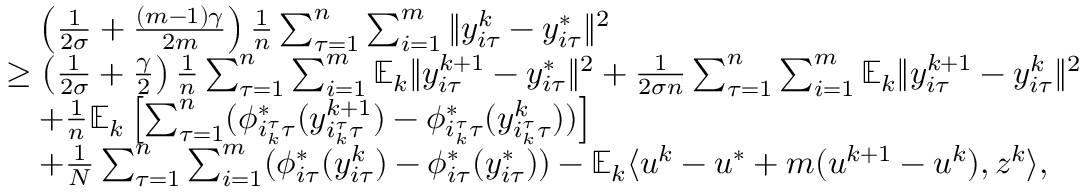<formula> <loc_0><loc_0><loc_500><loc_500>\begin{array} { r l } & { \quad \left ( \frac { 1 } { 2 \sigma } + \frac { ( m - 1 ) \gamma } { 2 m } \right ) \frac { 1 } { n } \sum _ { \tau = 1 } ^ { n } \sum _ { i = 1 } ^ { m } \| y _ { i \tau } ^ { k } - y _ { i \tau } ^ { * } \| ^ { 2 } } \\ & { \geq \left ( \frac { 1 } { 2 \sigma } + \frac { \gamma } { 2 } \right ) \frac { 1 } { n } \sum _ { \tau = 1 } ^ { n } \sum _ { i = 1 } ^ { m } \mathbb { E } _ { k } \| y _ { i \tau } ^ { k + 1 } - y _ { i \tau } ^ { * } \| ^ { 2 } + \frac { 1 } { 2 \sigma n } \sum _ { \tau = 1 } ^ { n } \sum _ { i = 1 } ^ { m } \mathbb { E } _ { k } \| y _ { i \tau } ^ { k + 1 } - y _ { i \tau } ^ { k } \| ^ { 2 } } \\ & { \quad + \frac { 1 } { n } \mathbb { E } _ { k } \left [ \sum _ { \tau = 1 } ^ { n } ( \phi _ { i _ { k } ^ { \tau } \tau } ^ { * } ( y _ { i _ { k } ^ { \tau } \tau } ^ { k + 1 } ) - \phi _ { i _ { k } ^ { \tau } \tau } ^ { * } ( y _ { i _ { k } ^ { \tau } \tau } ^ { k } ) ) \right ] } \\ & { \quad + \frac { 1 } { N } \sum _ { \tau = 1 } ^ { n } \sum _ { i = 1 } ^ { m } ( \phi _ { i \tau } ^ { * } ( y _ { i \tau } ^ { k } ) - \phi _ { i \tau } ^ { * } ( y _ { i \tau } ^ { * } ) ) - \mathbb { E } _ { k } \langle u ^ { k } - u ^ { * } + m ( u ^ { k + 1 } - u ^ { k } ) , z ^ { k } \rangle , } \end{array}</formula> 